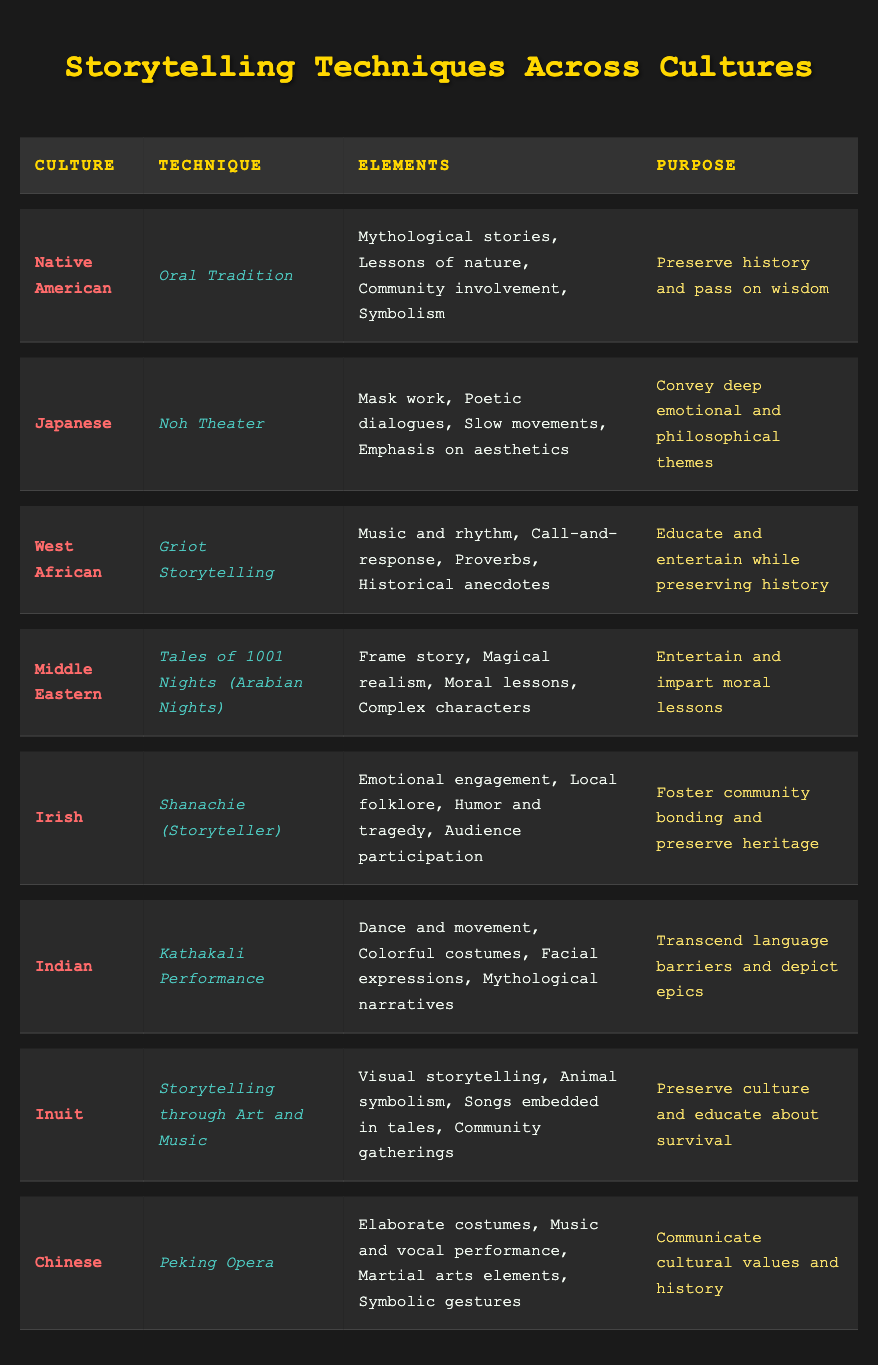What storytelling technique is used in West African culture? The table includes a row for West African culture, which states that the technique used is Griot Storytelling.
Answer: Griot Storytelling What purpose does Inuit storytelling serve? By looking at the row for Inuit culture, we find that the purpose is to preserve culture and educate about survival.
Answer: Preserve culture and educate about survival How many storytelling techniques involve musical elements? From the table, we see that both Griot Storytelling (West African) and Storytelling through Art and Music (Inuit) mention music. Thus, there are 2 techniques that involve musical elements.
Answer: 2 Do all cultures listed share the same purpose of educating their audience? By examining the purposes listed in each culture's row, it becomes clear that not all cultures focus solely on education. Some prioritize entertainment and moral lessons as well.
Answer: No Which storytelling techniques emphasize community involvement? The Native American Oral Tradition highlights community involvement; the West African Griot Storytelling involves call-and-response, which typically requires community participation; and the Irish Shanachie encourages audience participation. So, there are three techniques that emphasize community involvement.
Answer: 3 What are the unique elements found in the Japanese Noh Theater technique? The table indicates that the unique elements of Noh Theater are mask work, poetic dialogues, slow movements, and an emphasis on aesthetics.
Answer: Mask work, poetic dialogues, slow movements, emphasis on aesthetics Which cultures use humor as part of their storytelling techniques? The table shows that the Irish Shanachie incorporates humor and tragedy as part of its elements, and no other technique listed explicitly mentions humor.
Answer: Irish What is the commonality in the purposes of Native American and Indian storytelling techniques? Both cultural storytelling techniques aim to preserve history and pass on wisdom; however, the Indian Kathakali Performance also emphasizes transcending language barriers. Thus, the commonality lies in the preservation and sharing of cultural narratives.
Answer: Both preserve history and pass on wisdom 